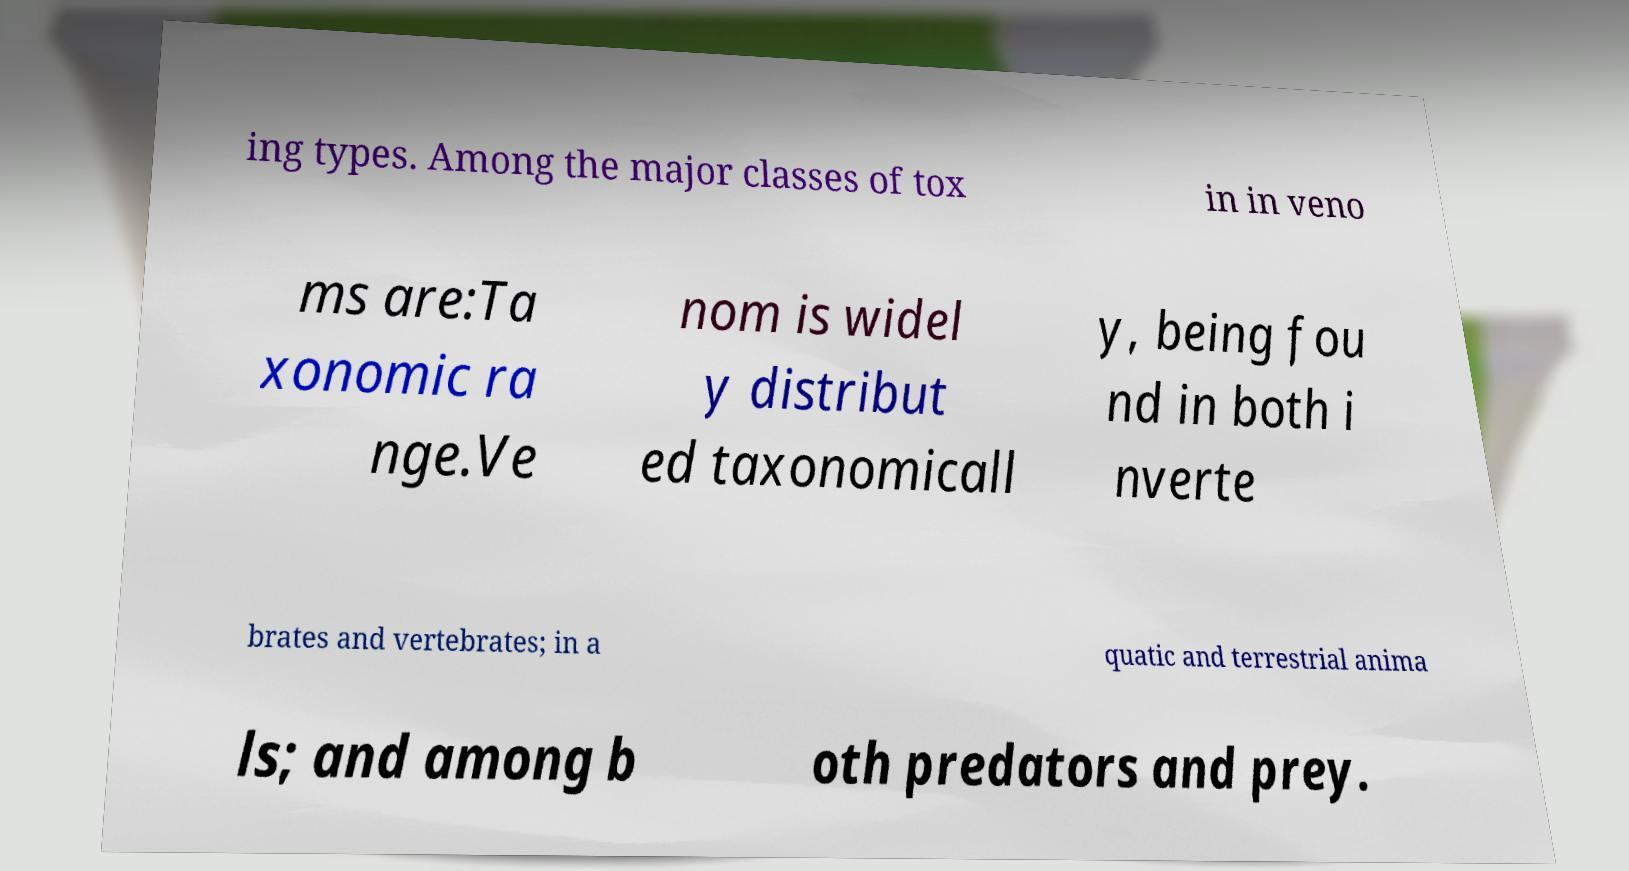Could you extract and type out the text from this image? ing types. Among the major classes of tox in in veno ms are:Ta xonomic ra nge.Ve nom is widel y distribut ed taxonomicall y, being fou nd in both i nverte brates and vertebrates; in a quatic and terrestrial anima ls; and among b oth predators and prey. 